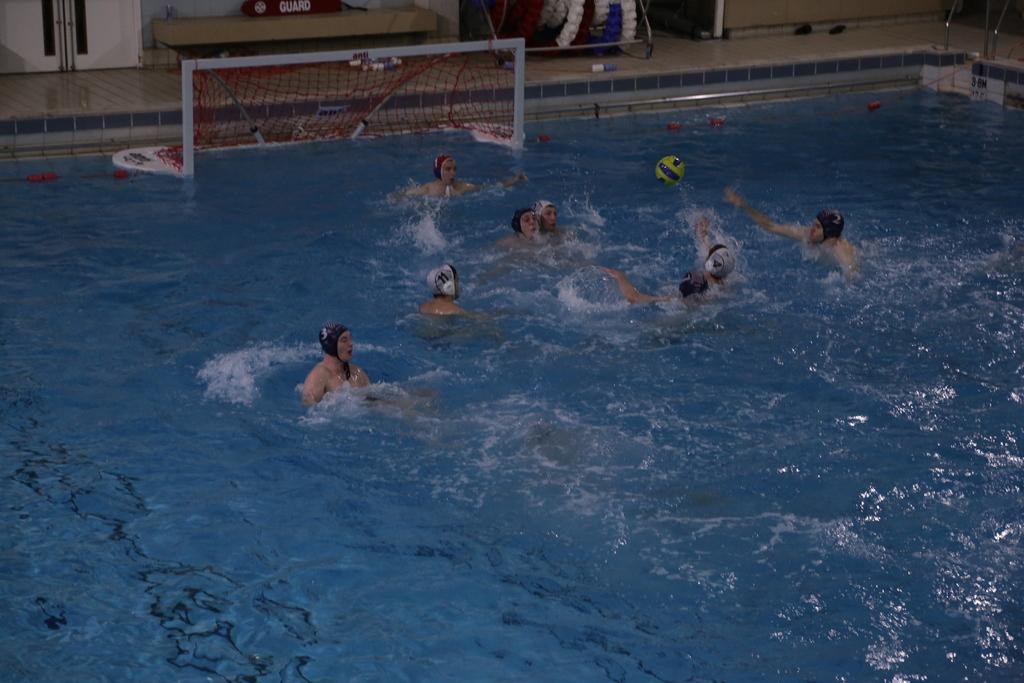What are the people in the image doing? The people in the image are playing in a swimming pool. What can be seen in the background of the image? There is a net visible in the background, and there are other objects present as well. What type of sheep can be seen in the image? There are no sheep present in the image; it features a group of people playing in a swimming pool. What is the queen doing in the image? There is no queen present in the image; it features a group of people playing in a swimming pool. 